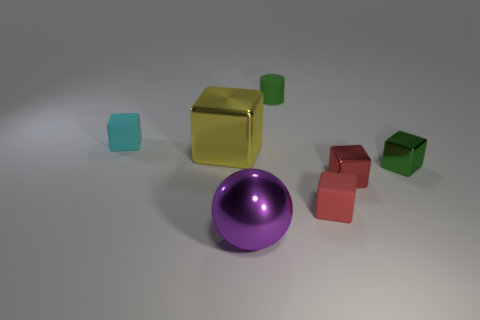Subtract all tiny blocks. How many blocks are left? 1 Subtract all cylinders. How many objects are left? 6 Add 2 big things. How many big things are left? 4 Add 5 large metal things. How many large metal things exist? 7 Add 2 green shiny blocks. How many objects exist? 9 Subtract all red blocks. How many blocks are left? 3 Subtract 0 cyan cylinders. How many objects are left? 7 Subtract 1 blocks. How many blocks are left? 4 Subtract all cyan blocks. Subtract all yellow cylinders. How many blocks are left? 4 Subtract all yellow balls. How many cyan blocks are left? 1 